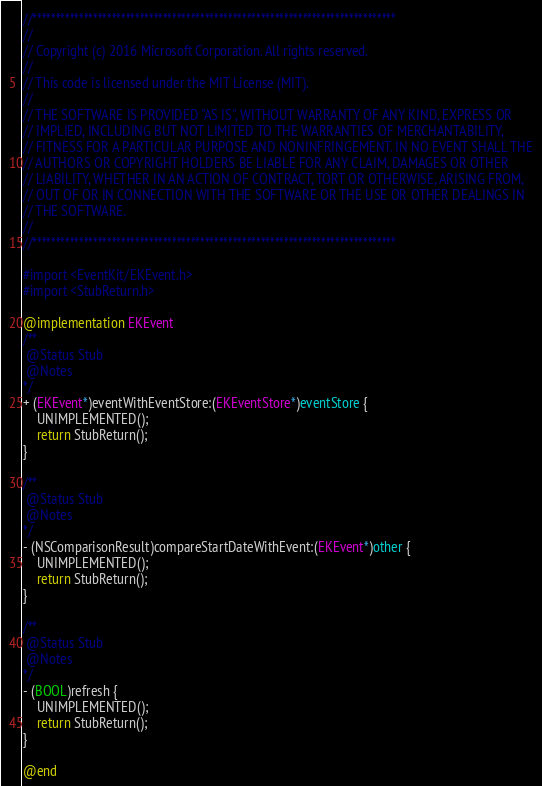Convert code to text. <code><loc_0><loc_0><loc_500><loc_500><_ObjectiveC_>//******************************************************************************
//
// Copyright (c) 2016 Microsoft Corporation. All rights reserved.
//
// This code is licensed under the MIT License (MIT).
//
// THE SOFTWARE IS PROVIDED "AS IS", WITHOUT WARRANTY OF ANY KIND, EXPRESS OR
// IMPLIED, INCLUDING BUT NOT LIMITED TO THE WARRANTIES OF MERCHANTABILITY,
// FITNESS FOR A PARTICULAR PURPOSE AND NONINFRINGEMENT. IN NO EVENT SHALL THE
// AUTHORS OR COPYRIGHT HOLDERS BE LIABLE FOR ANY CLAIM, DAMAGES OR OTHER
// LIABILITY, WHETHER IN AN ACTION OF CONTRACT, TORT OR OTHERWISE, ARISING FROM,
// OUT OF OR IN CONNECTION WITH THE SOFTWARE OR THE USE OR OTHER DEALINGS IN
// THE SOFTWARE.
//
//******************************************************************************

#import <EventKit/EKEvent.h>
#import <StubReturn.h>

@implementation EKEvent
/**
 @Status Stub
 @Notes
*/
+ (EKEvent*)eventWithEventStore:(EKEventStore*)eventStore {
    UNIMPLEMENTED();
    return StubReturn();
}

/**
 @Status Stub
 @Notes
*/
- (NSComparisonResult)compareStartDateWithEvent:(EKEvent*)other {
    UNIMPLEMENTED();
    return StubReturn();
}

/**
 @Status Stub
 @Notes
*/
- (BOOL)refresh {
    UNIMPLEMENTED();
    return StubReturn();
}

@end
</code> 